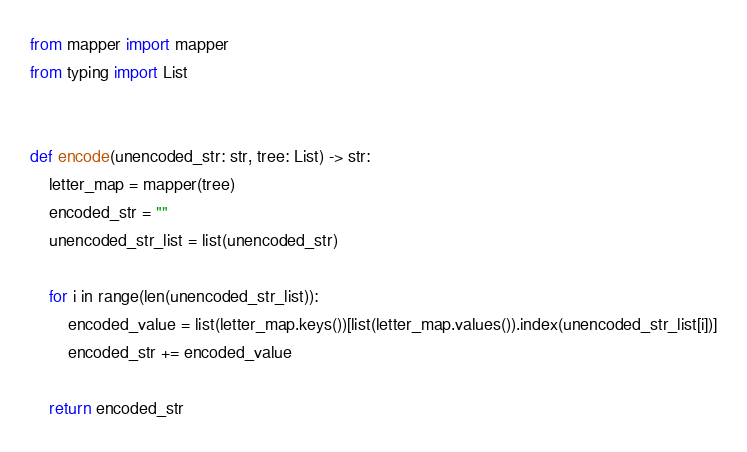<code> <loc_0><loc_0><loc_500><loc_500><_Python_>from mapper import mapper
from typing import List


def encode(unencoded_str: str, tree: List) -> str:
    letter_map = mapper(tree)
    encoded_str = ""
    unencoded_str_list = list(unencoded_str)

    for i in range(len(unencoded_str_list)):
        encoded_value = list(letter_map.keys())[list(letter_map.values()).index(unencoded_str_list[i])]
        encoded_str += encoded_value

    return encoded_str
</code> 